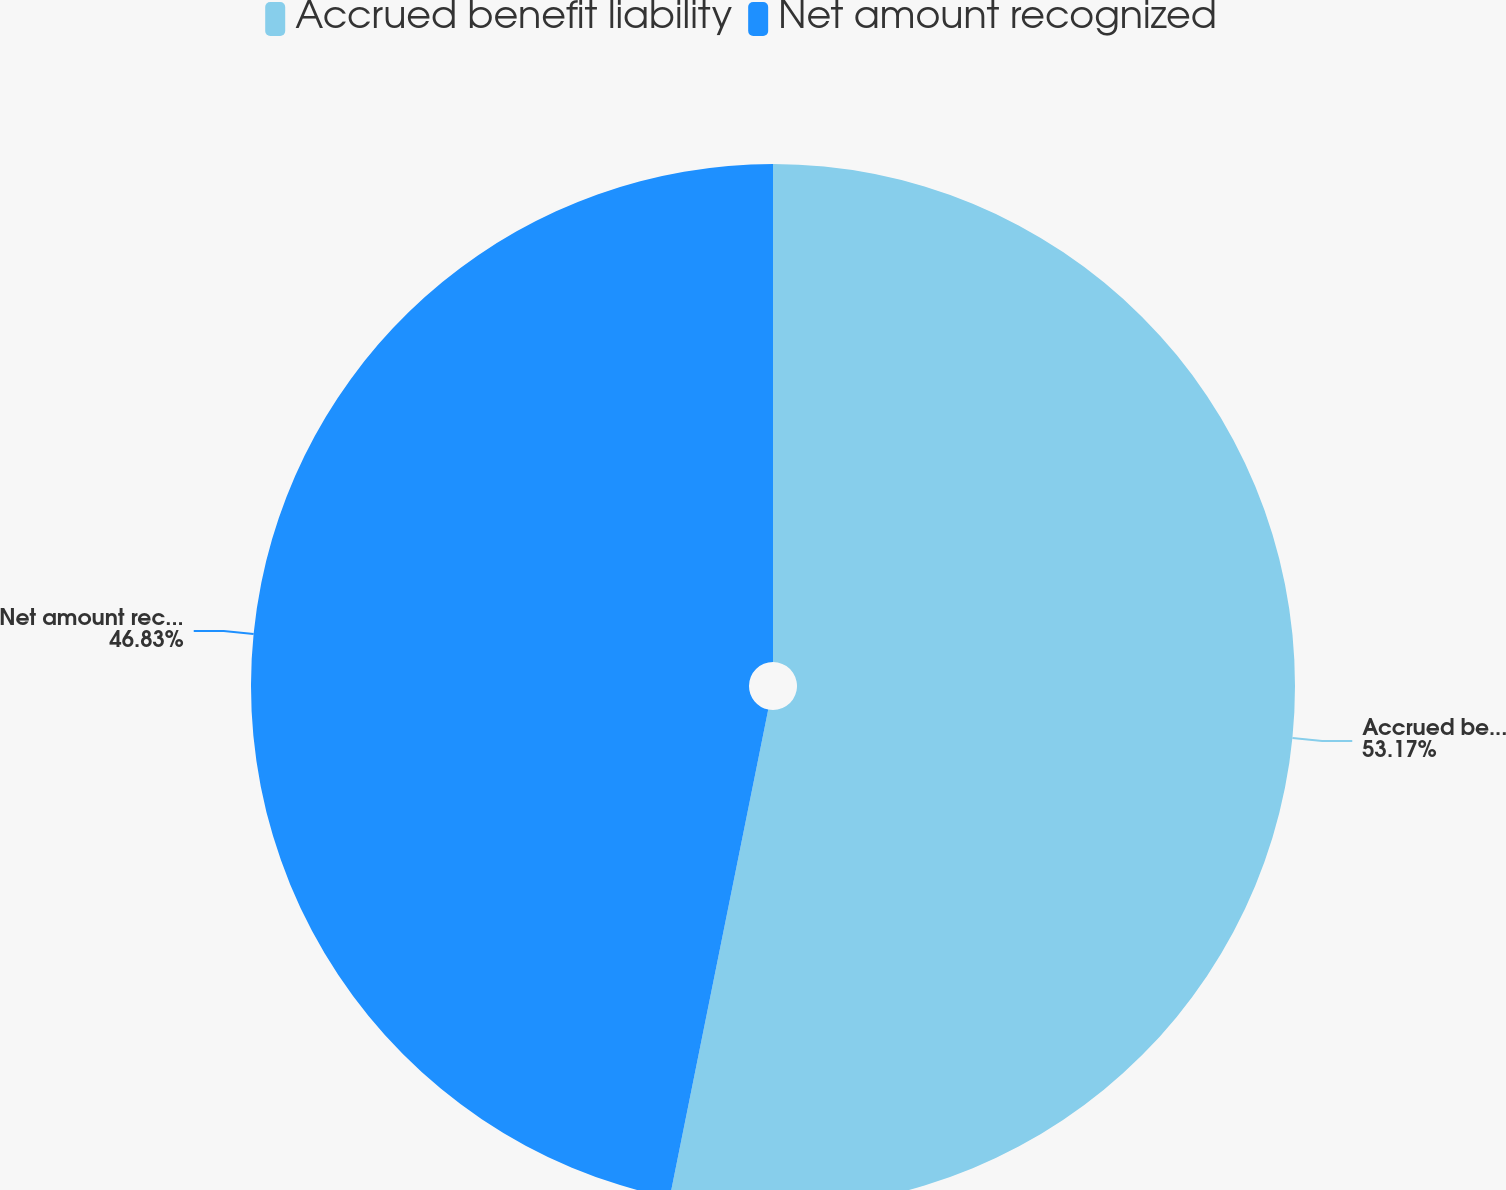Convert chart. <chart><loc_0><loc_0><loc_500><loc_500><pie_chart><fcel>Accrued benefit liability<fcel>Net amount recognized<nl><fcel>53.17%<fcel>46.83%<nl></chart> 